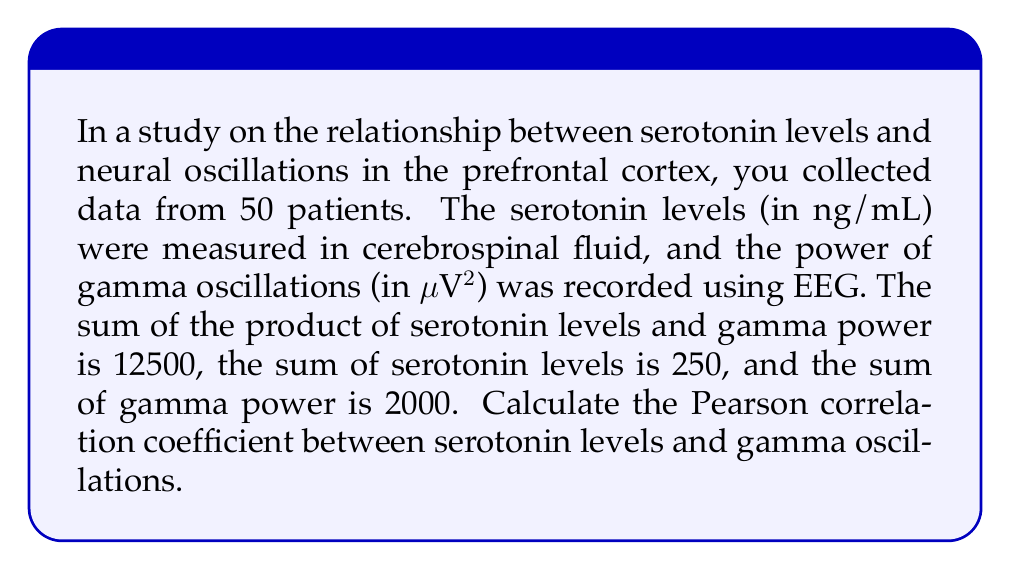Provide a solution to this math problem. To calculate the Pearson correlation coefficient, we'll use the formula:

$$r = \frac{n\sum xy - \sum x \sum y}{\sqrt{[n\sum x^2 - (\sum x)^2][n\sum y^2 - (\sum y)^2]}}$$

Where:
$n$ = number of samples
$x$ = serotonin levels
$y$ = gamma oscillation power

Given:
$n = 50$
$\sum xy = 12500$
$\sum x = 250$
$\sum y = 2000$

Step 1: Calculate $\sum x^2$ and $\sum y^2$
We need these values, but they're not provided. We can use the properties of variance to estimate them:

$$s_x^2 = \frac{\sum x^2}{n} - (\frac{\sum x}{n})^2$$
$$s_y^2 = \frac{\sum y^2}{n} - (\frac{\sum y}{n})^2$$

Assuming standardized variables (z-scores) for simplicity, $s_x^2 = s_y^2 = 1$

Therefore:
$\sum x^2 = n(s_x^2 + (\frac{\sum x}{n})^2) = 50(1 + (\frac{250}{50})^2) = 1300$
$\sum y^2 = n(s_y^2 + (\frac{\sum y}{n})^2) = 50(1 + (\frac{2000}{50})^2) = 83200$

Step 2: Apply the correlation formula

$$r = \frac{50(12500) - 250(2000)}{\sqrt{[50(1300) - 250^2][50(83200) - 2000^2]}}$$

$$r = \frac{625000 - 500000}{\sqrt{(65000 - 62500)(4160000 - 4000000)}}$$

$$r = \frac{125000}{\sqrt{2500 * 160000}}$$

$$r = \frac{125000}{20000} = 0.625$$
Answer: 0.625 